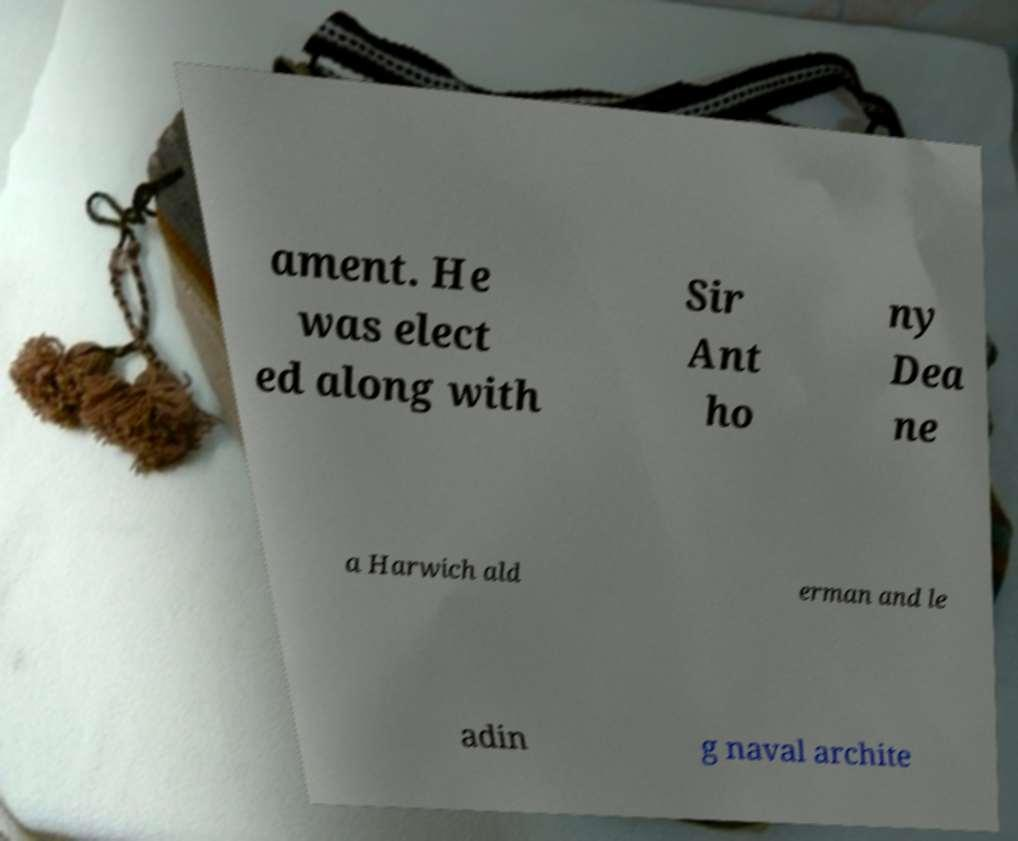There's text embedded in this image that I need extracted. Can you transcribe it verbatim? ament. He was elect ed along with Sir Ant ho ny Dea ne a Harwich ald erman and le adin g naval archite 